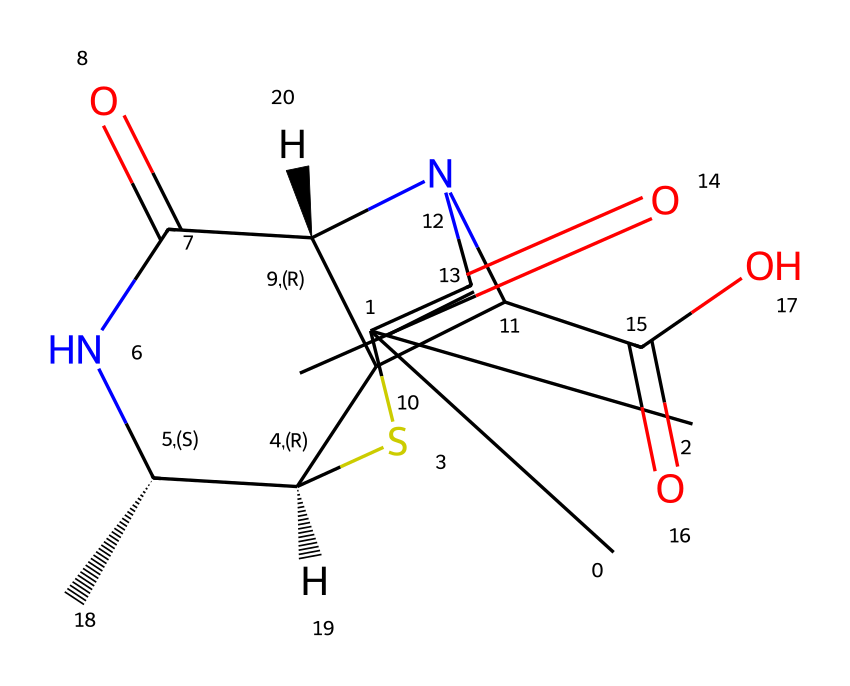What is the main functional group present in this chemical? The structure includes a carboxylic acid functional group, indicated by the presence of -COOH.
Answer: carboxylic acid How many chiral centers does this compound have? By analyzing the stereocenters in the structure, there are two carbons that are bonded to four different groups, indicating two chiral centers.
Answer: two What type of compound is represented by this SMILES notation? This structure represents a beta-lactam antibiotic, as it contains a beta-lactam ring which is characteristic of penicillin derivatives.
Answer: beta-lactam antibiotic Does this compound contain any nitrogen atoms? Upon examining the structure, there are two nitrogen atoms present, which facilitates the amine and amide functionalities of the compound.
Answer: yes How many rings are present in the chemical structure? Counting the rings in the diagram, there are three distinct cyclic structures as seen in the structure of this antibiotic.
Answer: three What is the significance of the sulfur atom in this compound? The sulfur atom in the structure plays a crucial role in the stability and functionality of the beta-lactam ring, which is important for antibiotic activity.
Answer: stability 